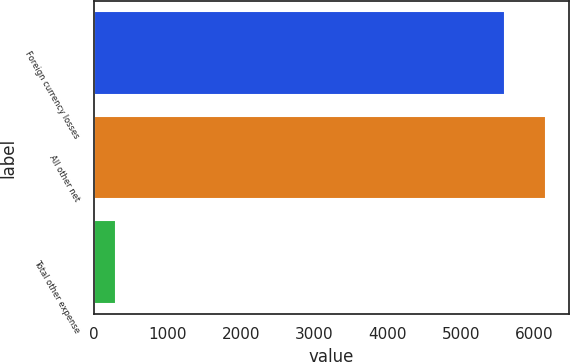Convert chart to OTSL. <chart><loc_0><loc_0><loc_500><loc_500><bar_chart><fcel>Foreign currency losses<fcel>All other net<fcel>Total other expense<nl><fcel>5599<fcel>6158.9<fcel>303<nl></chart> 